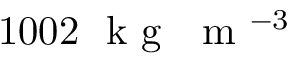Convert formula to latex. <formula><loc_0><loc_0><loc_500><loc_500>1 0 0 2 k g m ^ { - 3 }</formula> 